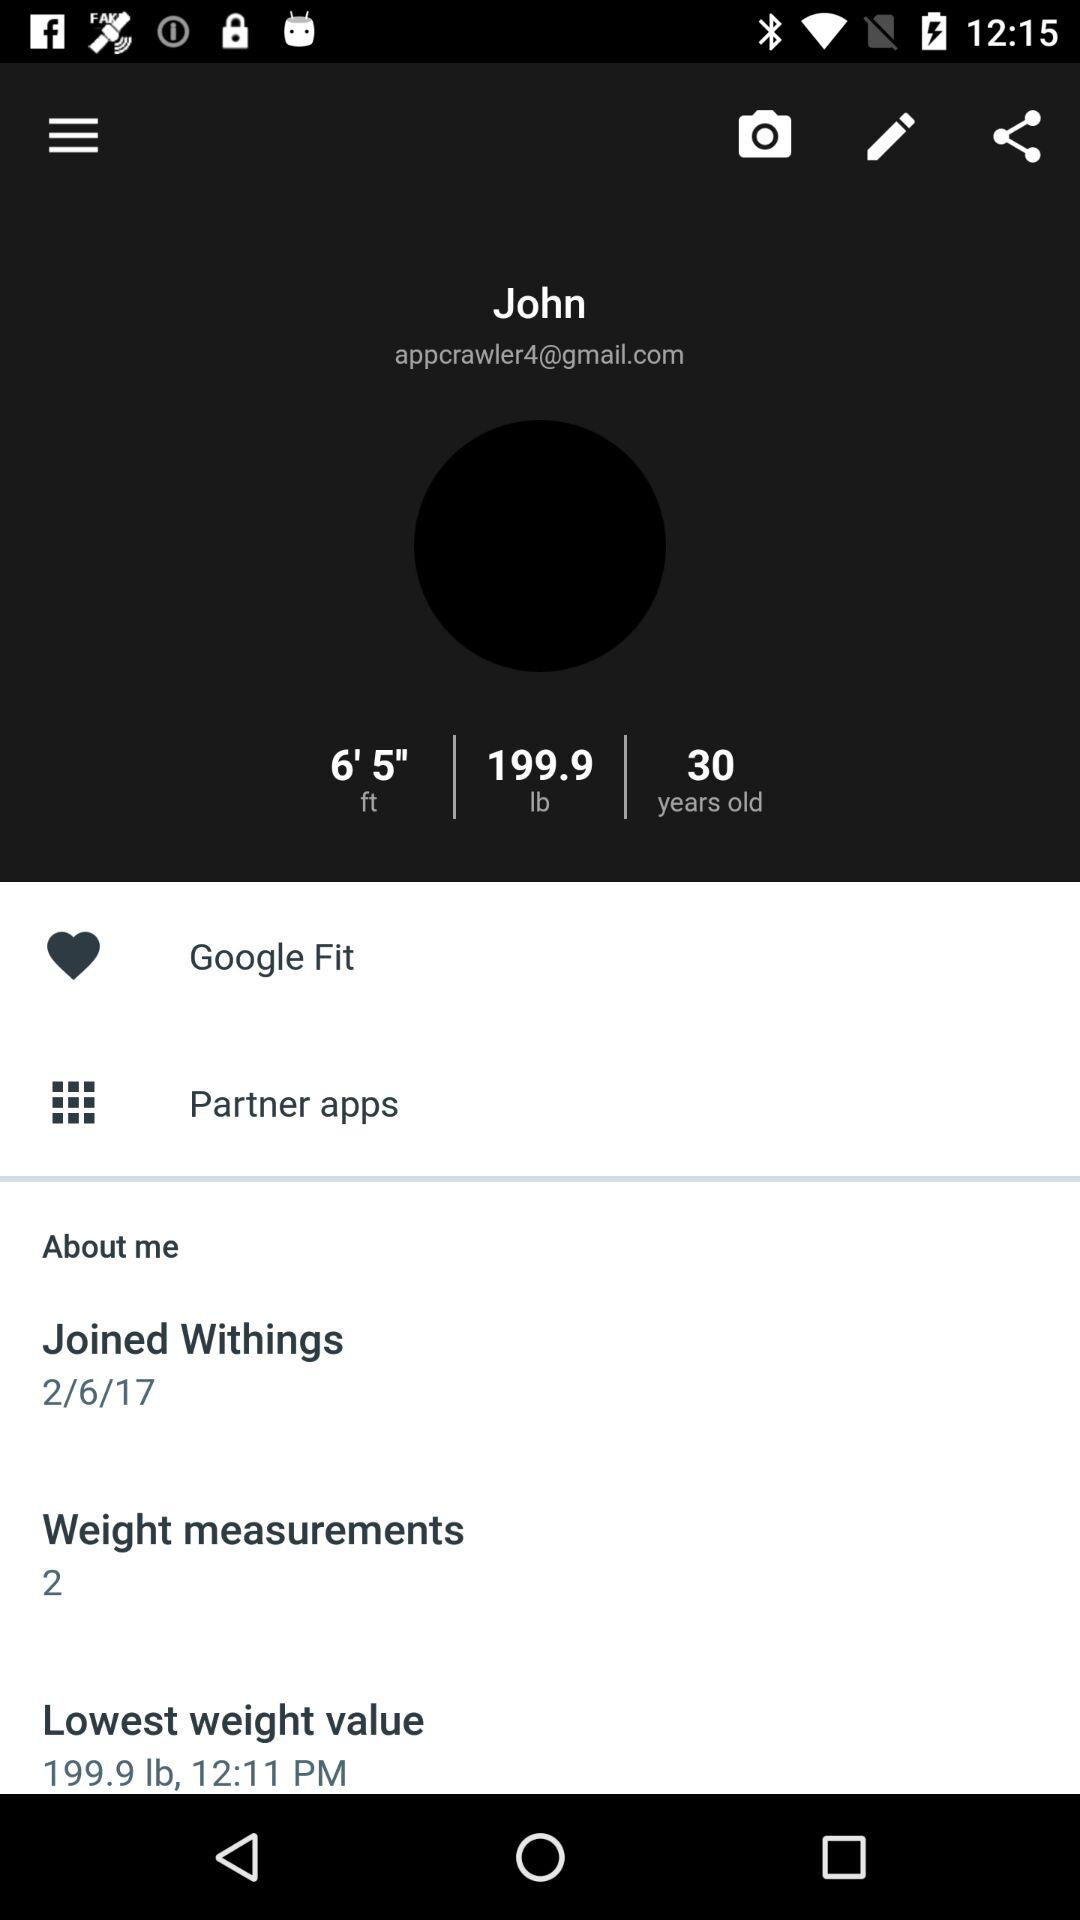How many pounds is John's lowest weight value?
Answer the question using a single word or phrase. 199.9 